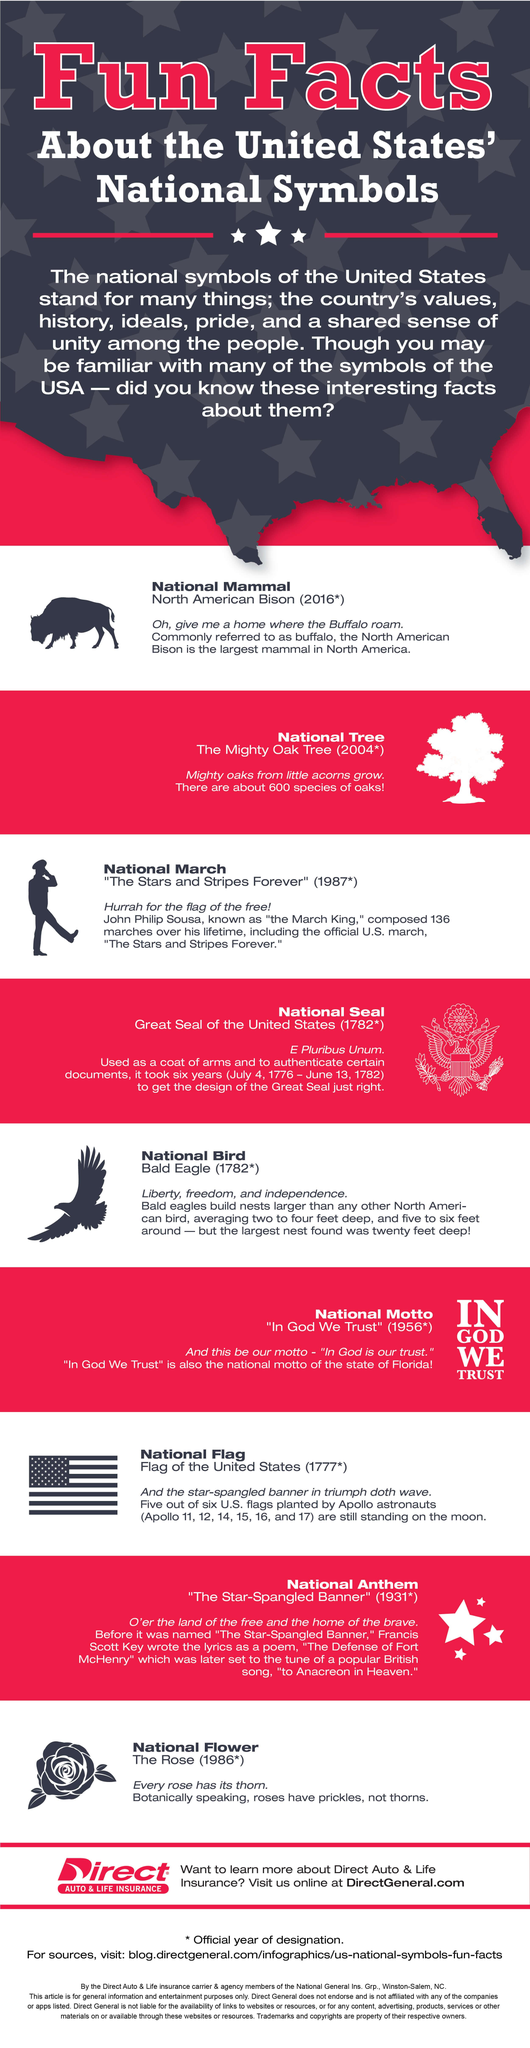Identify some key points in this picture. The finalized symbol for the national mammal was decided last. The national symbol that was finalized before the national tree is the national march. The flags that were left on the moon by the Apollo 11, 12, 14, 15, 16, and 17 missions are still present there. The bison is also known as the buffalo. In 1782, a total of two symbols were finalized. 